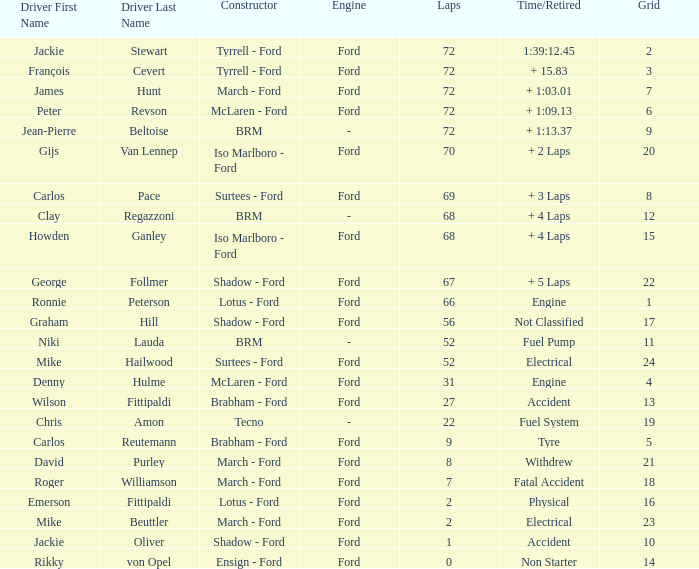What is the top grid that roger williamson lapped less than 7? None. 